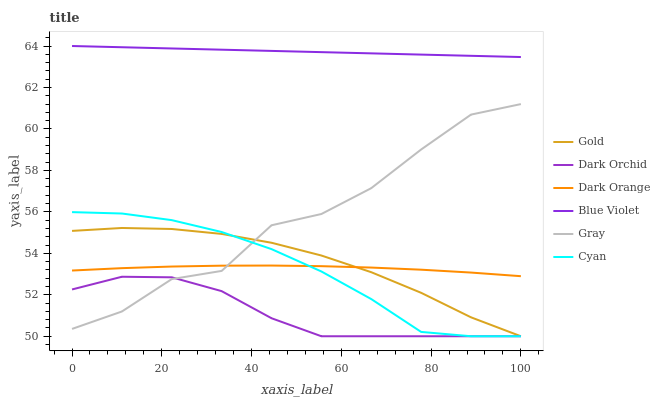Does Dark Orchid have the minimum area under the curve?
Answer yes or no. Yes. Does Blue Violet have the maximum area under the curve?
Answer yes or no. Yes. Does Gold have the minimum area under the curve?
Answer yes or no. No. Does Gold have the maximum area under the curve?
Answer yes or no. No. Is Blue Violet the smoothest?
Answer yes or no. Yes. Is Gray the roughest?
Answer yes or no. Yes. Is Gold the smoothest?
Answer yes or no. No. Is Gold the roughest?
Answer yes or no. No. Does Gold have the lowest value?
Answer yes or no. Yes. Does Gray have the lowest value?
Answer yes or no. No. Does Blue Violet have the highest value?
Answer yes or no. Yes. Does Gold have the highest value?
Answer yes or no. No. Is Gray less than Blue Violet?
Answer yes or no. Yes. Is Blue Violet greater than Dark Orange?
Answer yes or no. Yes. Does Dark Orchid intersect Gold?
Answer yes or no. Yes. Is Dark Orchid less than Gold?
Answer yes or no. No. Is Dark Orchid greater than Gold?
Answer yes or no. No. Does Gray intersect Blue Violet?
Answer yes or no. No. 